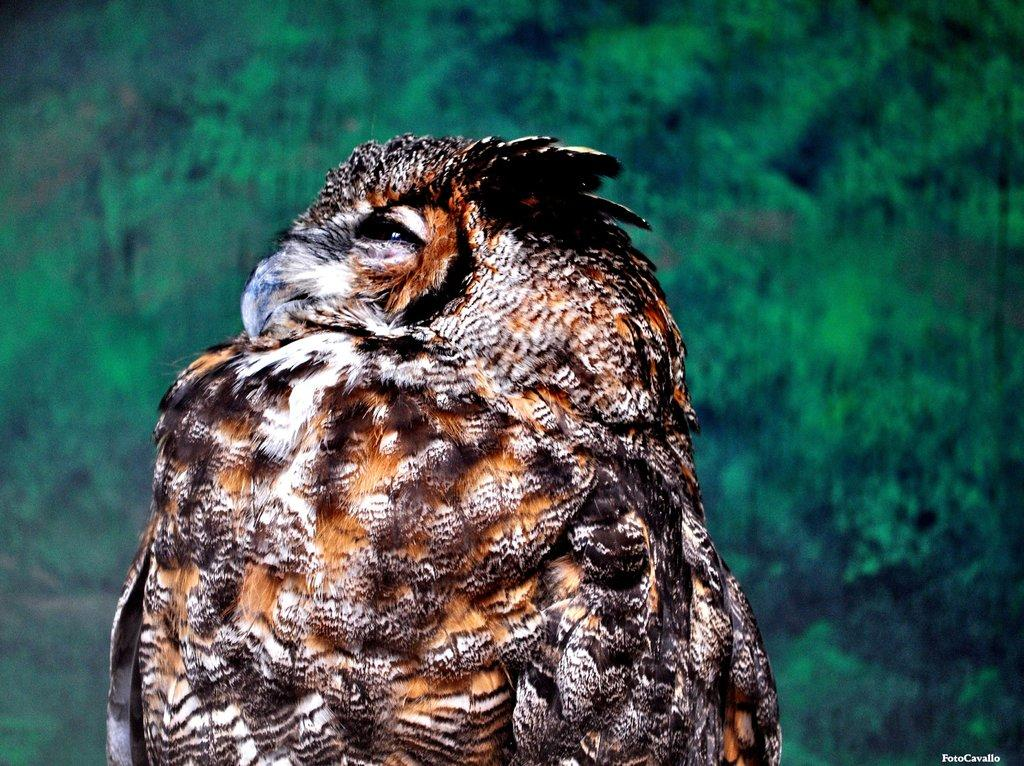What animal is present in the image? There is an owl in the image. What can be seen in the background of the image? There are trees in the background of the image. Is there any text present in the image? Yes, there is some text at the bottom of the image. Who is the owner of the wooden office furniture in the image? There is no wooden office furniture present in the image. 